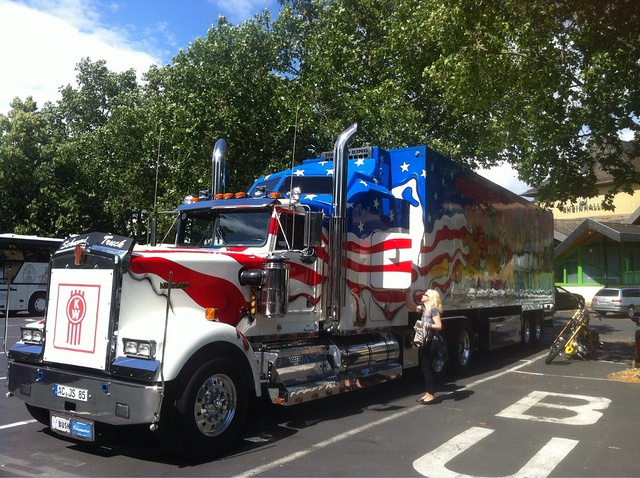Describe the objects in this image and their specific colors. I can see truck in lavender, black, gray, white, and maroon tones, bus in lavender, black, gray, and white tones, motorcycle in lavender, black, and gray tones, people in lavender, black, beige, tan, and gray tones, and car in lavender, gray, black, darkgray, and lightgray tones in this image. 